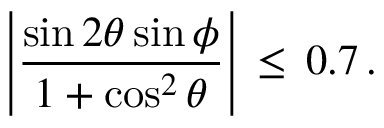Convert formula to latex. <formula><loc_0><loc_0><loc_500><loc_500>\left | \frac { \sin 2 \theta \sin \phi } { 1 + \cos ^ { 2 } \theta } \right | \, \leq \, 0 . 7 \, .</formula> 